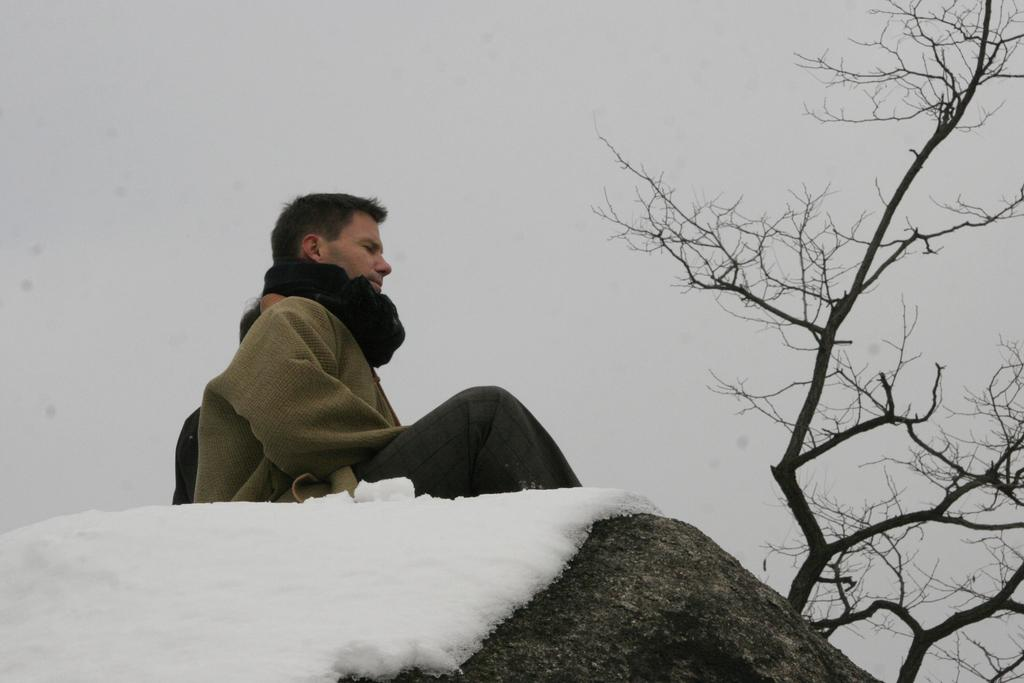What is the main subject of the image? There is a person in the image. What is the person wearing? The person is wearing a jacket. Where is the person sitting? The person is sitting on a hill. What is the condition of the hill? The hill is covered with snow. What else can be seen in the image? There is a tree in the image. How would you describe the background of the image? The background of the image is plain. What type of vegetable is being harvested in the image? There is no vegetable being harvested in the image; it features a person sitting on a snow-covered hill. What year is the image from? The year the image was taken is not mentioned in the provided facts, so it cannot be determined. 